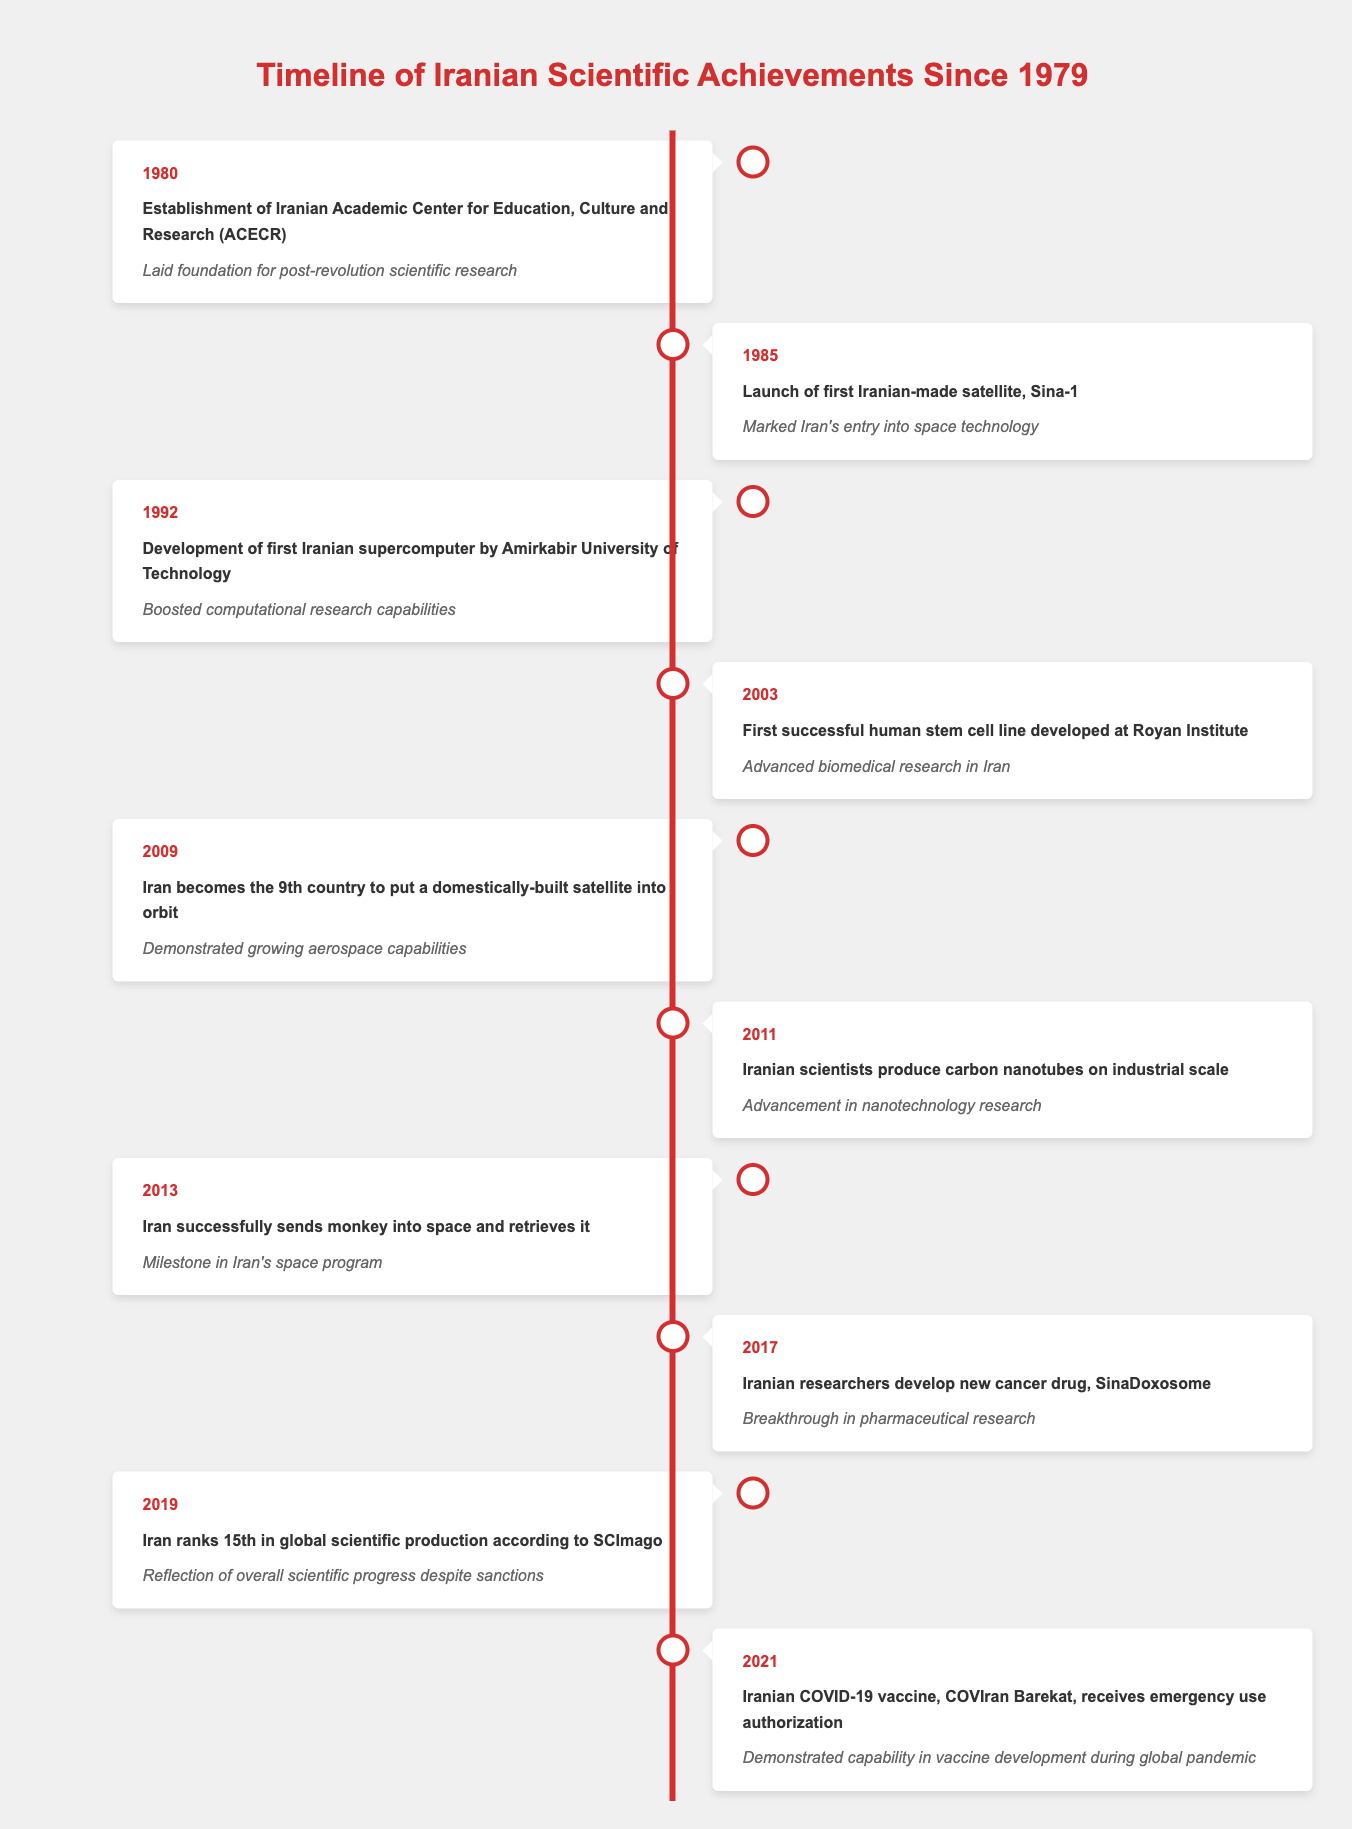What year was the first Iranian-made satellite launched? The table shows that the first Iranian-made satellite, Sina-1, was launched in 1985.
Answer: 1985 Which achievement is significant for biomedical research in Iran? According to the table, the first successful human stem cell line developed at Royan Institute in 2003 advanced biomedical research in Iran.
Answer: First successful human stem cell line developed at Royan Institute in 2003 What was the most recent scientific achievement listed in the timeline? The timeline shows that the most recent scientific achievement is the emergency use authorization of the Iranian COVID-19 vaccine, COVIran Barekat, in 2021.
Answer: Iranian COVID-19 vaccine authorized in 2021 Did Iran produce carbon nanotubes on an industrial scale before 2015? The timeline indicates that Iranian scientists produced carbon nanotubes on an industrial scale in 2011, which is before 2015.
Answer: Yes What is the significance of Iran's ranking in global scientific production in 2019? The table states that in 2019, Iran ranked 15th in global scientific production according to SCImago, reflecting overall scientific progress despite sanctions.
Answer: Progress despite sanctions How many years are there between the establishment of the ACECR and the launch of the first Iranian-made satellite? The establishment of ACECR occurred in 1980 and the first Iranian-made satellite was launched in 1985. The difference is 5 years (1985 - 1980 = 5).
Answer: 5 years What advancements in space technology did Iran achieve by 2009? The table shows that by 2009, Iran became the 9th country to put a domestically-built satellite into orbit, demonstrating significant advancements in aerospace capabilities.
Answer: Became 9th country in 2009 How many significant achievements are listed in the timeline between 2000 and 2020? According to the timeline, there are five significant achievements listed from the years 2003 (first human stem cell line) to 2021 (COVID-19 vaccine). These years are 2003, 2009, 2011, 2013, 2017, and 2019; counting these gives a total of 6 achievements.
Answer: 6 achievements 